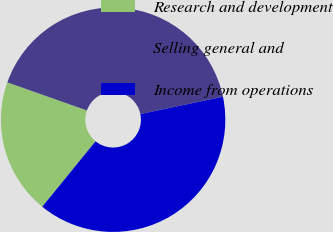<chart> <loc_0><loc_0><loc_500><loc_500><pie_chart><fcel>Research and development<fcel>Selling general and<fcel>Income from operations<nl><fcel>19.53%<fcel>41.32%<fcel>39.16%<nl></chart> 